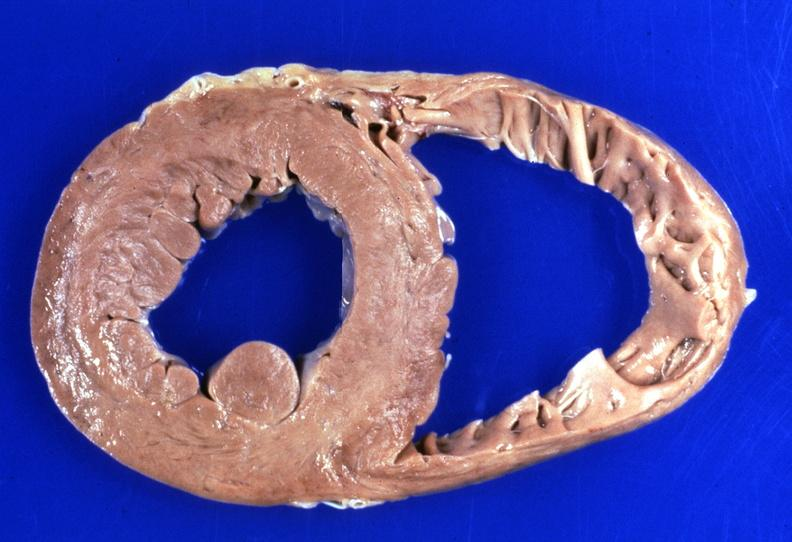where is this?
Answer the question using a single word or phrase. Heart 